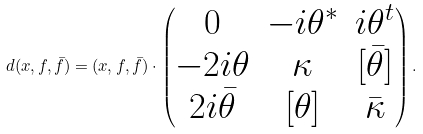Convert formula to latex. <formula><loc_0><loc_0><loc_500><loc_500>d ( x , f , \bar { f } ) = ( x , f , \bar { f } ) \cdot \begin{pmatrix} 0 & - i \theta ^ { * } & i \theta ^ { t } \\ - 2 i \theta & \kappa & [ \bar { \theta } ] \\ 2 i \bar { \theta } & [ \theta ] & \bar { \kappa } \end{pmatrix} .</formula> 